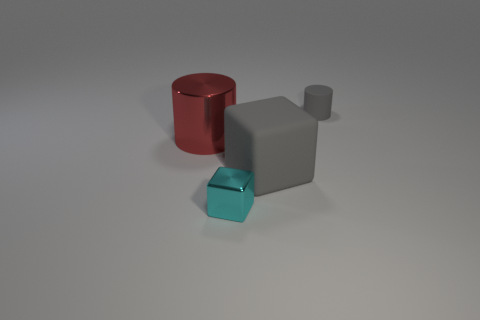Add 1 small shiny cubes. How many objects exist? 5 Add 4 big rubber cubes. How many big rubber cubes exist? 5 Subtract 0 purple spheres. How many objects are left? 4 Subtract all large brown cubes. Subtract all large red objects. How many objects are left? 3 Add 2 large cylinders. How many large cylinders are left? 3 